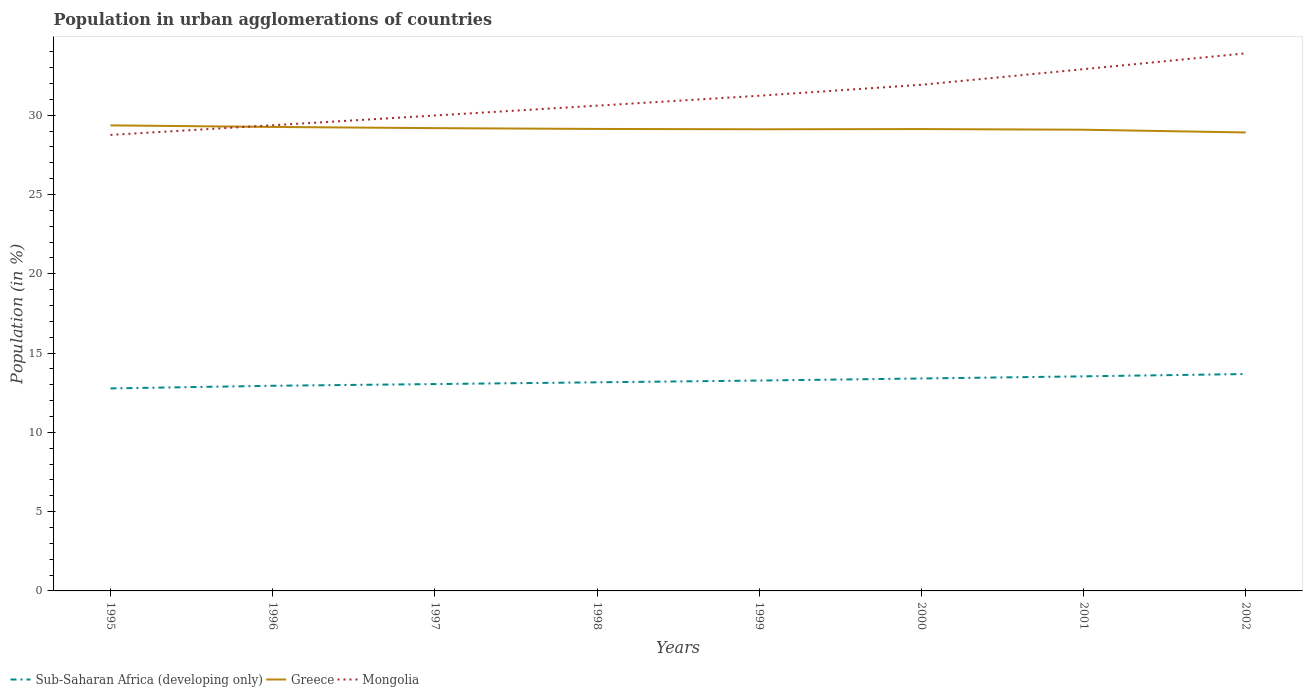Is the number of lines equal to the number of legend labels?
Your answer should be compact. Yes. Across all years, what is the maximum percentage of population in urban agglomerations in Greece?
Your response must be concise. 28.91. In which year was the percentage of population in urban agglomerations in Sub-Saharan Africa (developing only) maximum?
Your answer should be compact. 1995. What is the total percentage of population in urban agglomerations in Sub-Saharan Africa (developing only) in the graph?
Provide a short and direct response. -0.17. What is the difference between the highest and the second highest percentage of population in urban agglomerations in Greece?
Your answer should be very brief. 0.45. What is the difference between two consecutive major ticks on the Y-axis?
Keep it short and to the point. 5. Are the values on the major ticks of Y-axis written in scientific E-notation?
Your answer should be very brief. No. Does the graph contain grids?
Ensure brevity in your answer.  No. Where does the legend appear in the graph?
Keep it short and to the point. Bottom left. What is the title of the graph?
Offer a very short reply. Population in urban agglomerations of countries. Does "Oman" appear as one of the legend labels in the graph?
Your answer should be compact. No. What is the Population (in %) of Sub-Saharan Africa (developing only) in 1995?
Keep it short and to the point. 12.77. What is the Population (in %) of Greece in 1995?
Your answer should be compact. 29.35. What is the Population (in %) in Mongolia in 1995?
Your response must be concise. 28.75. What is the Population (in %) in Sub-Saharan Africa (developing only) in 1996?
Offer a terse response. 12.94. What is the Population (in %) in Greece in 1996?
Ensure brevity in your answer.  29.26. What is the Population (in %) of Mongolia in 1996?
Give a very brief answer. 29.36. What is the Population (in %) of Sub-Saharan Africa (developing only) in 1997?
Offer a very short reply. 13.04. What is the Population (in %) of Greece in 1997?
Offer a terse response. 29.18. What is the Population (in %) of Mongolia in 1997?
Your answer should be compact. 29.98. What is the Population (in %) of Sub-Saharan Africa (developing only) in 1998?
Your response must be concise. 13.15. What is the Population (in %) of Greece in 1998?
Provide a short and direct response. 29.13. What is the Population (in %) in Mongolia in 1998?
Make the answer very short. 30.6. What is the Population (in %) of Sub-Saharan Africa (developing only) in 1999?
Give a very brief answer. 13.27. What is the Population (in %) in Greece in 1999?
Your answer should be compact. 29.11. What is the Population (in %) in Mongolia in 1999?
Ensure brevity in your answer.  31.22. What is the Population (in %) of Sub-Saharan Africa (developing only) in 2000?
Make the answer very short. 13.4. What is the Population (in %) of Greece in 2000?
Offer a very short reply. 29.12. What is the Population (in %) of Mongolia in 2000?
Offer a very short reply. 31.91. What is the Population (in %) of Sub-Saharan Africa (developing only) in 2001?
Keep it short and to the point. 13.53. What is the Population (in %) in Greece in 2001?
Make the answer very short. 29.08. What is the Population (in %) in Mongolia in 2001?
Offer a very short reply. 32.9. What is the Population (in %) in Sub-Saharan Africa (developing only) in 2002?
Your answer should be compact. 13.67. What is the Population (in %) in Greece in 2002?
Offer a terse response. 28.91. What is the Population (in %) of Mongolia in 2002?
Provide a short and direct response. 33.9. Across all years, what is the maximum Population (in %) of Sub-Saharan Africa (developing only)?
Offer a very short reply. 13.67. Across all years, what is the maximum Population (in %) of Greece?
Keep it short and to the point. 29.35. Across all years, what is the maximum Population (in %) in Mongolia?
Ensure brevity in your answer.  33.9. Across all years, what is the minimum Population (in %) of Sub-Saharan Africa (developing only)?
Your answer should be compact. 12.77. Across all years, what is the minimum Population (in %) in Greece?
Your answer should be compact. 28.91. Across all years, what is the minimum Population (in %) in Mongolia?
Offer a very short reply. 28.75. What is the total Population (in %) in Sub-Saharan Africa (developing only) in the graph?
Your answer should be very brief. 105.77. What is the total Population (in %) in Greece in the graph?
Offer a terse response. 233.14. What is the total Population (in %) of Mongolia in the graph?
Your answer should be very brief. 248.62. What is the difference between the Population (in %) of Sub-Saharan Africa (developing only) in 1995 and that in 1996?
Provide a succinct answer. -0.17. What is the difference between the Population (in %) of Greece in 1995 and that in 1996?
Provide a succinct answer. 0.1. What is the difference between the Population (in %) of Mongolia in 1995 and that in 1996?
Provide a succinct answer. -0.61. What is the difference between the Population (in %) of Sub-Saharan Africa (developing only) in 1995 and that in 1997?
Provide a succinct answer. -0.27. What is the difference between the Population (in %) of Greece in 1995 and that in 1997?
Your answer should be compact. 0.17. What is the difference between the Population (in %) of Mongolia in 1995 and that in 1997?
Provide a succinct answer. -1.22. What is the difference between the Population (in %) of Sub-Saharan Africa (developing only) in 1995 and that in 1998?
Provide a short and direct response. -0.38. What is the difference between the Population (in %) in Greece in 1995 and that in 1998?
Offer a terse response. 0.22. What is the difference between the Population (in %) of Mongolia in 1995 and that in 1998?
Your answer should be very brief. -1.84. What is the difference between the Population (in %) in Sub-Saharan Africa (developing only) in 1995 and that in 1999?
Ensure brevity in your answer.  -0.5. What is the difference between the Population (in %) in Greece in 1995 and that in 1999?
Offer a very short reply. 0.25. What is the difference between the Population (in %) in Mongolia in 1995 and that in 1999?
Ensure brevity in your answer.  -2.47. What is the difference between the Population (in %) of Sub-Saharan Africa (developing only) in 1995 and that in 2000?
Provide a succinct answer. -0.63. What is the difference between the Population (in %) in Greece in 1995 and that in 2000?
Ensure brevity in your answer.  0.23. What is the difference between the Population (in %) of Mongolia in 1995 and that in 2000?
Ensure brevity in your answer.  -3.16. What is the difference between the Population (in %) of Sub-Saharan Africa (developing only) in 1995 and that in 2001?
Provide a short and direct response. -0.76. What is the difference between the Population (in %) in Greece in 1995 and that in 2001?
Make the answer very short. 0.27. What is the difference between the Population (in %) in Mongolia in 1995 and that in 2001?
Give a very brief answer. -4.14. What is the difference between the Population (in %) in Sub-Saharan Africa (developing only) in 1995 and that in 2002?
Your response must be concise. -0.91. What is the difference between the Population (in %) of Greece in 1995 and that in 2002?
Offer a very short reply. 0.45. What is the difference between the Population (in %) of Mongolia in 1995 and that in 2002?
Give a very brief answer. -5.14. What is the difference between the Population (in %) of Sub-Saharan Africa (developing only) in 1996 and that in 1997?
Your answer should be compact. -0.11. What is the difference between the Population (in %) of Greece in 1996 and that in 1997?
Make the answer very short. 0.08. What is the difference between the Population (in %) in Mongolia in 1996 and that in 1997?
Offer a very short reply. -0.61. What is the difference between the Population (in %) in Sub-Saharan Africa (developing only) in 1996 and that in 1998?
Offer a terse response. -0.22. What is the difference between the Population (in %) in Greece in 1996 and that in 1998?
Make the answer very short. 0.13. What is the difference between the Population (in %) in Mongolia in 1996 and that in 1998?
Give a very brief answer. -1.23. What is the difference between the Population (in %) of Sub-Saharan Africa (developing only) in 1996 and that in 1999?
Provide a short and direct response. -0.33. What is the difference between the Population (in %) in Greece in 1996 and that in 1999?
Ensure brevity in your answer.  0.15. What is the difference between the Population (in %) of Mongolia in 1996 and that in 1999?
Make the answer very short. -1.86. What is the difference between the Population (in %) of Sub-Saharan Africa (developing only) in 1996 and that in 2000?
Keep it short and to the point. -0.46. What is the difference between the Population (in %) in Greece in 1996 and that in 2000?
Your answer should be compact. 0.13. What is the difference between the Population (in %) in Mongolia in 1996 and that in 2000?
Ensure brevity in your answer.  -2.55. What is the difference between the Population (in %) of Sub-Saharan Africa (developing only) in 1996 and that in 2001?
Offer a terse response. -0.6. What is the difference between the Population (in %) in Greece in 1996 and that in 2001?
Offer a very short reply. 0.18. What is the difference between the Population (in %) of Mongolia in 1996 and that in 2001?
Provide a succinct answer. -3.54. What is the difference between the Population (in %) of Sub-Saharan Africa (developing only) in 1996 and that in 2002?
Make the answer very short. -0.74. What is the difference between the Population (in %) of Greece in 1996 and that in 2002?
Offer a very short reply. 0.35. What is the difference between the Population (in %) of Mongolia in 1996 and that in 2002?
Offer a very short reply. -4.53. What is the difference between the Population (in %) of Sub-Saharan Africa (developing only) in 1997 and that in 1998?
Your answer should be very brief. -0.11. What is the difference between the Population (in %) in Greece in 1997 and that in 1998?
Make the answer very short. 0.05. What is the difference between the Population (in %) in Mongolia in 1997 and that in 1998?
Your response must be concise. -0.62. What is the difference between the Population (in %) of Sub-Saharan Africa (developing only) in 1997 and that in 1999?
Offer a terse response. -0.22. What is the difference between the Population (in %) in Greece in 1997 and that in 1999?
Offer a very short reply. 0.07. What is the difference between the Population (in %) in Mongolia in 1997 and that in 1999?
Your response must be concise. -1.25. What is the difference between the Population (in %) of Sub-Saharan Africa (developing only) in 1997 and that in 2000?
Your answer should be compact. -0.35. What is the difference between the Population (in %) in Greece in 1997 and that in 2000?
Provide a succinct answer. 0.06. What is the difference between the Population (in %) in Mongolia in 1997 and that in 2000?
Your answer should be compact. -1.94. What is the difference between the Population (in %) in Sub-Saharan Africa (developing only) in 1997 and that in 2001?
Offer a very short reply. -0.49. What is the difference between the Population (in %) of Greece in 1997 and that in 2001?
Ensure brevity in your answer.  0.1. What is the difference between the Population (in %) in Mongolia in 1997 and that in 2001?
Provide a succinct answer. -2.92. What is the difference between the Population (in %) in Sub-Saharan Africa (developing only) in 1997 and that in 2002?
Give a very brief answer. -0.63. What is the difference between the Population (in %) in Greece in 1997 and that in 2002?
Your answer should be compact. 0.27. What is the difference between the Population (in %) in Mongolia in 1997 and that in 2002?
Offer a terse response. -3.92. What is the difference between the Population (in %) of Sub-Saharan Africa (developing only) in 1998 and that in 1999?
Ensure brevity in your answer.  -0.11. What is the difference between the Population (in %) of Greece in 1998 and that in 1999?
Your response must be concise. 0.02. What is the difference between the Population (in %) in Mongolia in 1998 and that in 1999?
Your response must be concise. -0.63. What is the difference between the Population (in %) in Sub-Saharan Africa (developing only) in 1998 and that in 2000?
Your response must be concise. -0.24. What is the difference between the Population (in %) in Greece in 1998 and that in 2000?
Your answer should be compact. 0.01. What is the difference between the Population (in %) in Mongolia in 1998 and that in 2000?
Provide a short and direct response. -1.32. What is the difference between the Population (in %) in Sub-Saharan Africa (developing only) in 1998 and that in 2001?
Provide a succinct answer. -0.38. What is the difference between the Population (in %) in Greece in 1998 and that in 2001?
Your response must be concise. 0.05. What is the difference between the Population (in %) in Mongolia in 1998 and that in 2001?
Your answer should be compact. -2.3. What is the difference between the Population (in %) of Sub-Saharan Africa (developing only) in 1998 and that in 2002?
Ensure brevity in your answer.  -0.52. What is the difference between the Population (in %) in Greece in 1998 and that in 2002?
Offer a very short reply. 0.22. What is the difference between the Population (in %) of Mongolia in 1998 and that in 2002?
Give a very brief answer. -3.3. What is the difference between the Population (in %) in Sub-Saharan Africa (developing only) in 1999 and that in 2000?
Your answer should be very brief. -0.13. What is the difference between the Population (in %) in Greece in 1999 and that in 2000?
Offer a terse response. -0.01. What is the difference between the Population (in %) in Mongolia in 1999 and that in 2000?
Make the answer very short. -0.69. What is the difference between the Population (in %) in Sub-Saharan Africa (developing only) in 1999 and that in 2001?
Provide a short and direct response. -0.27. What is the difference between the Population (in %) of Greece in 1999 and that in 2001?
Offer a very short reply. 0.03. What is the difference between the Population (in %) of Mongolia in 1999 and that in 2001?
Offer a very short reply. -1.68. What is the difference between the Population (in %) of Sub-Saharan Africa (developing only) in 1999 and that in 2002?
Offer a very short reply. -0.41. What is the difference between the Population (in %) in Greece in 1999 and that in 2002?
Offer a very short reply. 0.2. What is the difference between the Population (in %) of Mongolia in 1999 and that in 2002?
Offer a very short reply. -2.67. What is the difference between the Population (in %) of Sub-Saharan Africa (developing only) in 2000 and that in 2001?
Your answer should be compact. -0.14. What is the difference between the Population (in %) in Greece in 2000 and that in 2001?
Your answer should be compact. 0.04. What is the difference between the Population (in %) of Mongolia in 2000 and that in 2001?
Your answer should be compact. -0.98. What is the difference between the Population (in %) of Sub-Saharan Africa (developing only) in 2000 and that in 2002?
Offer a terse response. -0.28. What is the difference between the Population (in %) in Greece in 2000 and that in 2002?
Keep it short and to the point. 0.21. What is the difference between the Population (in %) of Mongolia in 2000 and that in 2002?
Your answer should be very brief. -1.98. What is the difference between the Population (in %) in Sub-Saharan Africa (developing only) in 2001 and that in 2002?
Keep it short and to the point. -0.14. What is the difference between the Population (in %) in Greece in 2001 and that in 2002?
Provide a short and direct response. 0.17. What is the difference between the Population (in %) in Mongolia in 2001 and that in 2002?
Your response must be concise. -1. What is the difference between the Population (in %) of Sub-Saharan Africa (developing only) in 1995 and the Population (in %) of Greece in 1996?
Offer a very short reply. -16.49. What is the difference between the Population (in %) in Sub-Saharan Africa (developing only) in 1995 and the Population (in %) in Mongolia in 1996?
Your answer should be compact. -16.59. What is the difference between the Population (in %) of Greece in 1995 and the Population (in %) of Mongolia in 1996?
Your response must be concise. -0.01. What is the difference between the Population (in %) in Sub-Saharan Africa (developing only) in 1995 and the Population (in %) in Greece in 1997?
Provide a short and direct response. -16.41. What is the difference between the Population (in %) of Sub-Saharan Africa (developing only) in 1995 and the Population (in %) of Mongolia in 1997?
Provide a short and direct response. -17.21. What is the difference between the Population (in %) in Greece in 1995 and the Population (in %) in Mongolia in 1997?
Provide a short and direct response. -0.62. What is the difference between the Population (in %) in Sub-Saharan Africa (developing only) in 1995 and the Population (in %) in Greece in 1998?
Offer a very short reply. -16.36. What is the difference between the Population (in %) of Sub-Saharan Africa (developing only) in 1995 and the Population (in %) of Mongolia in 1998?
Offer a terse response. -17.83. What is the difference between the Population (in %) of Greece in 1995 and the Population (in %) of Mongolia in 1998?
Your answer should be very brief. -1.24. What is the difference between the Population (in %) in Sub-Saharan Africa (developing only) in 1995 and the Population (in %) in Greece in 1999?
Your response must be concise. -16.34. What is the difference between the Population (in %) in Sub-Saharan Africa (developing only) in 1995 and the Population (in %) in Mongolia in 1999?
Your answer should be very brief. -18.45. What is the difference between the Population (in %) of Greece in 1995 and the Population (in %) of Mongolia in 1999?
Your answer should be compact. -1.87. What is the difference between the Population (in %) of Sub-Saharan Africa (developing only) in 1995 and the Population (in %) of Greece in 2000?
Give a very brief answer. -16.35. What is the difference between the Population (in %) of Sub-Saharan Africa (developing only) in 1995 and the Population (in %) of Mongolia in 2000?
Your response must be concise. -19.15. What is the difference between the Population (in %) in Greece in 1995 and the Population (in %) in Mongolia in 2000?
Your answer should be compact. -2.56. What is the difference between the Population (in %) of Sub-Saharan Africa (developing only) in 1995 and the Population (in %) of Greece in 2001?
Your answer should be very brief. -16.31. What is the difference between the Population (in %) in Sub-Saharan Africa (developing only) in 1995 and the Population (in %) in Mongolia in 2001?
Your response must be concise. -20.13. What is the difference between the Population (in %) in Greece in 1995 and the Population (in %) in Mongolia in 2001?
Provide a short and direct response. -3.54. What is the difference between the Population (in %) in Sub-Saharan Africa (developing only) in 1995 and the Population (in %) in Greece in 2002?
Keep it short and to the point. -16.14. What is the difference between the Population (in %) of Sub-Saharan Africa (developing only) in 1995 and the Population (in %) of Mongolia in 2002?
Give a very brief answer. -21.13. What is the difference between the Population (in %) of Greece in 1995 and the Population (in %) of Mongolia in 2002?
Your answer should be compact. -4.54. What is the difference between the Population (in %) in Sub-Saharan Africa (developing only) in 1996 and the Population (in %) in Greece in 1997?
Provide a short and direct response. -16.24. What is the difference between the Population (in %) of Sub-Saharan Africa (developing only) in 1996 and the Population (in %) of Mongolia in 1997?
Provide a succinct answer. -17.04. What is the difference between the Population (in %) of Greece in 1996 and the Population (in %) of Mongolia in 1997?
Ensure brevity in your answer.  -0.72. What is the difference between the Population (in %) of Sub-Saharan Africa (developing only) in 1996 and the Population (in %) of Greece in 1998?
Your response must be concise. -16.19. What is the difference between the Population (in %) in Sub-Saharan Africa (developing only) in 1996 and the Population (in %) in Mongolia in 1998?
Provide a succinct answer. -17.66. What is the difference between the Population (in %) in Greece in 1996 and the Population (in %) in Mongolia in 1998?
Your answer should be compact. -1.34. What is the difference between the Population (in %) of Sub-Saharan Africa (developing only) in 1996 and the Population (in %) of Greece in 1999?
Keep it short and to the point. -16.17. What is the difference between the Population (in %) in Sub-Saharan Africa (developing only) in 1996 and the Population (in %) in Mongolia in 1999?
Ensure brevity in your answer.  -18.29. What is the difference between the Population (in %) in Greece in 1996 and the Population (in %) in Mongolia in 1999?
Ensure brevity in your answer.  -1.97. What is the difference between the Population (in %) in Sub-Saharan Africa (developing only) in 1996 and the Population (in %) in Greece in 2000?
Provide a succinct answer. -16.19. What is the difference between the Population (in %) of Sub-Saharan Africa (developing only) in 1996 and the Population (in %) of Mongolia in 2000?
Your answer should be compact. -18.98. What is the difference between the Population (in %) of Greece in 1996 and the Population (in %) of Mongolia in 2000?
Your response must be concise. -2.66. What is the difference between the Population (in %) of Sub-Saharan Africa (developing only) in 1996 and the Population (in %) of Greece in 2001?
Offer a terse response. -16.15. What is the difference between the Population (in %) of Sub-Saharan Africa (developing only) in 1996 and the Population (in %) of Mongolia in 2001?
Offer a terse response. -19.96. What is the difference between the Population (in %) of Greece in 1996 and the Population (in %) of Mongolia in 2001?
Ensure brevity in your answer.  -3.64. What is the difference between the Population (in %) of Sub-Saharan Africa (developing only) in 1996 and the Population (in %) of Greece in 2002?
Your answer should be compact. -15.97. What is the difference between the Population (in %) of Sub-Saharan Africa (developing only) in 1996 and the Population (in %) of Mongolia in 2002?
Provide a short and direct response. -20.96. What is the difference between the Population (in %) of Greece in 1996 and the Population (in %) of Mongolia in 2002?
Your answer should be very brief. -4.64. What is the difference between the Population (in %) of Sub-Saharan Africa (developing only) in 1997 and the Population (in %) of Greece in 1998?
Offer a terse response. -16.09. What is the difference between the Population (in %) of Sub-Saharan Africa (developing only) in 1997 and the Population (in %) of Mongolia in 1998?
Offer a terse response. -17.55. What is the difference between the Population (in %) in Greece in 1997 and the Population (in %) in Mongolia in 1998?
Your response must be concise. -1.42. What is the difference between the Population (in %) in Sub-Saharan Africa (developing only) in 1997 and the Population (in %) in Greece in 1999?
Provide a succinct answer. -16.07. What is the difference between the Population (in %) in Sub-Saharan Africa (developing only) in 1997 and the Population (in %) in Mongolia in 1999?
Offer a terse response. -18.18. What is the difference between the Population (in %) in Greece in 1997 and the Population (in %) in Mongolia in 1999?
Your response must be concise. -2.04. What is the difference between the Population (in %) in Sub-Saharan Africa (developing only) in 1997 and the Population (in %) in Greece in 2000?
Give a very brief answer. -16.08. What is the difference between the Population (in %) of Sub-Saharan Africa (developing only) in 1997 and the Population (in %) of Mongolia in 2000?
Your answer should be very brief. -18.87. What is the difference between the Population (in %) in Greece in 1997 and the Population (in %) in Mongolia in 2000?
Give a very brief answer. -2.73. What is the difference between the Population (in %) in Sub-Saharan Africa (developing only) in 1997 and the Population (in %) in Greece in 2001?
Ensure brevity in your answer.  -16.04. What is the difference between the Population (in %) in Sub-Saharan Africa (developing only) in 1997 and the Population (in %) in Mongolia in 2001?
Give a very brief answer. -19.86. What is the difference between the Population (in %) in Greece in 1997 and the Population (in %) in Mongolia in 2001?
Your answer should be compact. -3.72. What is the difference between the Population (in %) in Sub-Saharan Africa (developing only) in 1997 and the Population (in %) in Greece in 2002?
Ensure brevity in your answer.  -15.86. What is the difference between the Population (in %) in Sub-Saharan Africa (developing only) in 1997 and the Population (in %) in Mongolia in 2002?
Your answer should be compact. -20.86. What is the difference between the Population (in %) of Greece in 1997 and the Population (in %) of Mongolia in 2002?
Make the answer very short. -4.72. What is the difference between the Population (in %) of Sub-Saharan Africa (developing only) in 1998 and the Population (in %) of Greece in 1999?
Make the answer very short. -15.95. What is the difference between the Population (in %) of Sub-Saharan Africa (developing only) in 1998 and the Population (in %) of Mongolia in 1999?
Provide a short and direct response. -18.07. What is the difference between the Population (in %) of Greece in 1998 and the Population (in %) of Mongolia in 1999?
Offer a very short reply. -2.09. What is the difference between the Population (in %) of Sub-Saharan Africa (developing only) in 1998 and the Population (in %) of Greece in 2000?
Provide a short and direct response. -15.97. What is the difference between the Population (in %) of Sub-Saharan Africa (developing only) in 1998 and the Population (in %) of Mongolia in 2000?
Your answer should be very brief. -18.76. What is the difference between the Population (in %) in Greece in 1998 and the Population (in %) in Mongolia in 2000?
Give a very brief answer. -2.78. What is the difference between the Population (in %) in Sub-Saharan Africa (developing only) in 1998 and the Population (in %) in Greece in 2001?
Make the answer very short. -15.93. What is the difference between the Population (in %) in Sub-Saharan Africa (developing only) in 1998 and the Population (in %) in Mongolia in 2001?
Your answer should be compact. -19.74. What is the difference between the Population (in %) in Greece in 1998 and the Population (in %) in Mongolia in 2001?
Provide a succinct answer. -3.77. What is the difference between the Population (in %) in Sub-Saharan Africa (developing only) in 1998 and the Population (in %) in Greece in 2002?
Make the answer very short. -15.75. What is the difference between the Population (in %) of Sub-Saharan Africa (developing only) in 1998 and the Population (in %) of Mongolia in 2002?
Ensure brevity in your answer.  -20.74. What is the difference between the Population (in %) of Greece in 1998 and the Population (in %) of Mongolia in 2002?
Provide a succinct answer. -4.77. What is the difference between the Population (in %) of Sub-Saharan Africa (developing only) in 1999 and the Population (in %) of Greece in 2000?
Ensure brevity in your answer.  -15.86. What is the difference between the Population (in %) in Sub-Saharan Africa (developing only) in 1999 and the Population (in %) in Mongolia in 2000?
Your answer should be very brief. -18.65. What is the difference between the Population (in %) in Greece in 1999 and the Population (in %) in Mongolia in 2000?
Your response must be concise. -2.81. What is the difference between the Population (in %) in Sub-Saharan Africa (developing only) in 1999 and the Population (in %) in Greece in 2001?
Your response must be concise. -15.82. What is the difference between the Population (in %) of Sub-Saharan Africa (developing only) in 1999 and the Population (in %) of Mongolia in 2001?
Ensure brevity in your answer.  -19.63. What is the difference between the Population (in %) in Greece in 1999 and the Population (in %) in Mongolia in 2001?
Make the answer very short. -3.79. What is the difference between the Population (in %) of Sub-Saharan Africa (developing only) in 1999 and the Population (in %) of Greece in 2002?
Give a very brief answer. -15.64. What is the difference between the Population (in %) in Sub-Saharan Africa (developing only) in 1999 and the Population (in %) in Mongolia in 2002?
Make the answer very short. -20.63. What is the difference between the Population (in %) in Greece in 1999 and the Population (in %) in Mongolia in 2002?
Your answer should be compact. -4.79. What is the difference between the Population (in %) in Sub-Saharan Africa (developing only) in 2000 and the Population (in %) in Greece in 2001?
Your answer should be very brief. -15.69. What is the difference between the Population (in %) of Sub-Saharan Africa (developing only) in 2000 and the Population (in %) of Mongolia in 2001?
Provide a short and direct response. -19.5. What is the difference between the Population (in %) of Greece in 2000 and the Population (in %) of Mongolia in 2001?
Provide a short and direct response. -3.78. What is the difference between the Population (in %) of Sub-Saharan Africa (developing only) in 2000 and the Population (in %) of Greece in 2002?
Your response must be concise. -15.51. What is the difference between the Population (in %) of Sub-Saharan Africa (developing only) in 2000 and the Population (in %) of Mongolia in 2002?
Make the answer very short. -20.5. What is the difference between the Population (in %) in Greece in 2000 and the Population (in %) in Mongolia in 2002?
Provide a short and direct response. -4.78. What is the difference between the Population (in %) of Sub-Saharan Africa (developing only) in 2001 and the Population (in %) of Greece in 2002?
Your response must be concise. -15.38. What is the difference between the Population (in %) in Sub-Saharan Africa (developing only) in 2001 and the Population (in %) in Mongolia in 2002?
Your response must be concise. -20.37. What is the difference between the Population (in %) in Greece in 2001 and the Population (in %) in Mongolia in 2002?
Keep it short and to the point. -4.82. What is the average Population (in %) of Sub-Saharan Africa (developing only) per year?
Your answer should be very brief. 13.22. What is the average Population (in %) of Greece per year?
Offer a very short reply. 29.14. What is the average Population (in %) in Mongolia per year?
Your response must be concise. 31.08. In the year 1995, what is the difference between the Population (in %) in Sub-Saharan Africa (developing only) and Population (in %) in Greece?
Provide a short and direct response. -16.59. In the year 1995, what is the difference between the Population (in %) in Sub-Saharan Africa (developing only) and Population (in %) in Mongolia?
Ensure brevity in your answer.  -15.98. In the year 1995, what is the difference between the Population (in %) of Greece and Population (in %) of Mongolia?
Give a very brief answer. 0.6. In the year 1996, what is the difference between the Population (in %) of Sub-Saharan Africa (developing only) and Population (in %) of Greece?
Give a very brief answer. -16.32. In the year 1996, what is the difference between the Population (in %) of Sub-Saharan Africa (developing only) and Population (in %) of Mongolia?
Give a very brief answer. -16.43. In the year 1996, what is the difference between the Population (in %) in Greece and Population (in %) in Mongolia?
Give a very brief answer. -0.11. In the year 1997, what is the difference between the Population (in %) of Sub-Saharan Africa (developing only) and Population (in %) of Greece?
Make the answer very short. -16.14. In the year 1997, what is the difference between the Population (in %) of Sub-Saharan Africa (developing only) and Population (in %) of Mongolia?
Give a very brief answer. -16.93. In the year 1997, what is the difference between the Population (in %) of Greece and Population (in %) of Mongolia?
Your answer should be compact. -0.8. In the year 1998, what is the difference between the Population (in %) in Sub-Saharan Africa (developing only) and Population (in %) in Greece?
Make the answer very short. -15.98. In the year 1998, what is the difference between the Population (in %) of Sub-Saharan Africa (developing only) and Population (in %) of Mongolia?
Offer a very short reply. -17.44. In the year 1998, what is the difference between the Population (in %) of Greece and Population (in %) of Mongolia?
Offer a terse response. -1.47. In the year 1999, what is the difference between the Population (in %) of Sub-Saharan Africa (developing only) and Population (in %) of Greece?
Make the answer very short. -15.84. In the year 1999, what is the difference between the Population (in %) of Sub-Saharan Africa (developing only) and Population (in %) of Mongolia?
Offer a terse response. -17.96. In the year 1999, what is the difference between the Population (in %) in Greece and Population (in %) in Mongolia?
Give a very brief answer. -2.11. In the year 2000, what is the difference between the Population (in %) in Sub-Saharan Africa (developing only) and Population (in %) in Greece?
Provide a short and direct response. -15.73. In the year 2000, what is the difference between the Population (in %) in Sub-Saharan Africa (developing only) and Population (in %) in Mongolia?
Your response must be concise. -18.52. In the year 2000, what is the difference between the Population (in %) of Greece and Population (in %) of Mongolia?
Provide a short and direct response. -2.79. In the year 2001, what is the difference between the Population (in %) of Sub-Saharan Africa (developing only) and Population (in %) of Greece?
Offer a terse response. -15.55. In the year 2001, what is the difference between the Population (in %) of Sub-Saharan Africa (developing only) and Population (in %) of Mongolia?
Your response must be concise. -19.37. In the year 2001, what is the difference between the Population (in %) in Greece and Population (in %) in Mongolia?
Your response must be concise. -3.82. In the year 2002, what is the difference between the Population (in %) in Sub-Saharan Africa (developing only) and Population (in %) in Greece?
Keep it short and to the point. -15.23. In the year 2002, what is the difference between the Population (in %) of Sub-Saharan Africa (developing only) and Population (in %) of Mongolia?
Provide a succinct answer. -20.22. In the year 2002, what is the difference between the Population (in %) of Greece and Population (in %) of Mongolia?
Give a very brief answer. -4.99. What is the ratio of the Population (in %) in Sub-Saharan Africa (developing only) in 1995 to that in 1996?
Give a very brief answer. 0.99. What is the ratio of the Population (in %) in Mongolia in 1995 to that in 1996?
Offer a very short reply. 0.98. What is the ratio of the Population (in %) in Sub-Saharan Africa (developing only) in 1995 to that in 1997?
Your response must be concise. 0.98. What is the ratio of the Population (in %) of Mongolia in 1995 to that in 1997?
Offer a terse response. 0.96. What is the ratio of the Population (in %) of Sub-Saharan Africa (developing only) in 1995 to that in 1998?
Give a very brief answer. 0.97. What is the ratio of the Population (in %) of Greece in 1995 to that in 1998?
Your answer should be very brief. 1.01. What is the ratio of the Population (in %) of Mongolia in 1995 to that in 1998?
Your answer should be compact. 0.94. What is the ratio of the Population (in %) in Sub-Saharan Africa (developing only) in 1995 to that in 1999?
Keep it short and to the point. 0.96. What is the ratio of the Population (in %) of Greece in 1995 to that in 1999?
Offer a very short reply. 1.01. What is the ratio of the Population (in %) of Mongolia in 1995 to that in 1999?
Make the answer very short. 0.92. What is the ratio of the Population (in %) in Sub-Saharan Africa (developing only) in 1995 to that in 2000?
Offer a very short reply. 0.95. What is the ratio of the Population (in %) of Greece in 1995 to that in 2000?
Ensure brevity in your answer.  1.01. What is the ratio of the Population (in %) in Mongolia in 1995 to that in 2000?
Your response must be concise. 0.9. What is the ratio of the Population (in %) in Sub-Saharan Africa (developing only) in 1995 to that in 2001?
Give a very brief answer. 0.94. What is the ratio of the Population (in %) in Greece in 1995 to that in 2001?
Make the answer very short. 1.01. What is the ratio of the Population (in %) in Mongolia in 1995 to that in 2001?
Your answer should be compact. 0.87. What is the ratio of the Population (in %) of Sub-Saharan Africa (developing only) in 1995 to that in 2002?
Keep it short and to the point. 0.93. What is the ratio of the Population (in %) of Greece in 1995 to that in 2002?
Provide a short and direct response. 1.02. What is the ratio of the Population (in %) of Mongolia in 1995 to that in 2002?
Ensure brevity in your answer.  0.85. What is the ratio of the Population (in %) of Mongolia in 1996 to that in 1997?
Ensure brevity in your answer.  0.98. What is the ratio of the Population (in %) in Sub-Saharan Africa (developing only) in 1996 to that in 1998?
Offer a terse response. 0.98. What is the ratio of the Population (in %) in Mongolia in 1996 to that in 1998?
Your answer should be very brief. 0.96. What is the ratio of the Population (in %) of Sub-Saharan Africa (developing only) in 1996 to that in 1999?
Make the answer very short. 0.98. What is the ratio of the Population (in %) in Greece in 1996 to that in 1999?
Make the answer very short. 1.01. What is the ratio of the Population (in %) of Mongolia in 1996 to that in 1999?
Your response must be concise. 0.94. What is the ratio of the Population (in %) in Sub-Saharan Africa (developing only) in 1996 to that in 2000?
Provide a succinct answer. 0.97. What is the ratio of the Population (in %) in Mongolia in 1996 to that in 2000?
Offer a terse response. 0.92. What is the ratio of the Population (in %) in Sub-Saharan Africa (developing only) in 1996 to that in 2001?
Make the answer very short. 0.96. What is the ratio of the Population (in %) of Greece in 1996 to that in 2001?
Provide a short and direct response. 1.01. What is the ratio of the Population (in %) of Mongolia in 1996 to that in 2001?
Offer a terse response. 0.89. What is the ratio of the Population (in %) in Sub-Saharan Africa (developing only) in 1996 to that in 2002?
Provide a succinct answer. 0.95. What is the ratio of the Population (in %) in Greece in 1996 to that in 2002?
Ensure brevity in your answer.  1.01. What is the ratio of the Population (in %) in Mongolia in 1996 to that in 2002?
Your response must be concise. 0.87. What is the ratio of the Population (in %) in Greece in 1997 to that in 1998?
Provide a succinct answer. 1. What is the ratio of the Population (in %) of Mongolia in 1997 to that in 1998?
Keep it short and to the point. 0.98. What is the ratio of the Population (in %) of Sub-Saharan Africa (developing only) in 1997 to that in 1999?
Offer a very short reply. 0.98. What is the ratio of the Population (in %) in Greece in 1997 to that in 1999?
Offer a very short reply. 1. What is the ratio of the Population (in %) in Mongolia in 1997 to that in 1999?
Your answer should be very brief. 0.96. What is the ratio of the Population (in %) of Sub-Saharan Africa (developing only) in 1997 to that in 2000?
Offer a terse response. 0.97. What is the ratio of the Population (in %) of Greece in 1997 to that in 2000?
Ensure brevity in your answer.  1. What is the ratio of the Population (in %) in Mongolia in 1997 to that in 2000?
Keep it short and to the point. 0.94. What is the ratio of the Population (in %) in Sub-Saharan Africa (developing only) in 1997 to that in 2001?
Offer a terse response. 0.96. What is the ratio of the Population (in %) of Greece in 1997 to that in 2001?
Provide a short and direct response. 1. What is the ratio of the Population (in %) in Mongolia in 1997 to that in 2001?
Make the answer very short. 0.91. What is the ratio of the Population (in %) in Sub-Saharan Africa (developing only) in 1997 to that in 2002?
Provide a short and direct response. 0.95. What is the ratio of the Population (in %) in Greece in 1997 to that in 2002?
Give a very brief answer. 1.01. What is the ratio of the Population (in %) of Mongolia in 1997 to that in 2002?
Make the answer very short. 0.88. What is the ratio of the Population (in %) of Sub-Saharan Africa (developing only) in 1998 to that in 1999?
Offer a terse response. 0.99. What is the ratio of the Population (in %) in Mongolia in 1998 to that in 1999?
Provide a short and direct response. 0.98. What is the ratio of the Population (in %) of Sub-Saharan Africa (developing only) in 1998 to that in 2000?
Your answer should be compact. 0.98. What is the ratio of the Population (in %) of Mongolia in 1998 to that in 2000?
Give a very brief answer. 0.96. What is the ratio of the Population (in %) of Sub-Saharan Africa (developing only) in 1998 to that in 2001?
Your answer should be very brief. 0.97. What is the ratio of the Population (in %) of Greece in 1998 to that in 2001?
Your response must be concise. 1. What is the ratio of the Population (in %) of Sub-Saharan Africa (developing only) in 1998 to that in 2002?
Make the answer very short. 0.96. What is the ratio of the Population (in %) of Greece in 1998 to that in 2002?
Provide a succinct answer. 1.01. What is the ratio of the Population (in %) of Mongolia in 1998 to that in 2002?
Your response must be concise. 0.9. What is the ratio of the Population (in %) of Sub-Saharan Africa (developing only) in 1999 to that in 2000?
Keep it short and to the point. 0.99. What is the ratio of the Population (in %) of Greece in 1999 to that in 2000?
Offer a terse response. 1. What is the ratio of the Population (in %) in Mongolia in 1999 to that in 2000?
Your answer should be very brief. 0.98. What is the ratio of the Population (in %) of Sub-Saharan Africa (developing only) in 1999 to that in 2001?
Offer a terse response. 0.98. What is the ratio of the Population (in %) in Greece in 1999 to that in 2001?
Provide a short and direct response. 1. What is the ratio of the Population (in %) in Mongolia in 1999 to that in 2001?
Provide a short and direct response. 0.95. What is the ratio of the Population (in %) in Sub-Saharan Africa (developing only) in 1999 to that in 2002?
Provide a succinct answer. 0.97. What is the ratio of the Population (in %) of Greece in 1999 to that in 2002?
Your answer should be very brief. 1.01. What is the ratio of the Population (in %) in Mongolia in 1999 to that in 2002?
Your answer should be very brief. 0.92. What is the ratio of the Population (in %) in Greece in 2000 to that in 2001?
Your answer should be very brief. 1. What is the ratio of the Population (in %) of Mongolia in 2000 to that in 2001?
Your answer should be very brief. 0.97. What is the ratio of the Population (in %) in Sub-Saharan Africa (developing only) in 2000 to that in 2002?
Your answer should be compact. 0.98. What is the ratio of the Population (in %) in Greece in 2000 to that in 2002?
Your answer should be compact. 1.01. What is the ratio of the Population (in %) in Mongolia in 2000 to that in 2002?
Offer a very short reply. 0.94. What is the ratio of the Population (in %) in Greece in 2001 to that in 2002?
Your answer should be very brief. 1.01. What is the ratio of the Population (in %) of Mongolia in 2001 to that in 2002?
Offer a very short reply. 0.97. What is the difference between the highest and the second highest Population (in %) in Sub-Saharan Africa (developing only)?
Ensure brevity in your answer.  0.14. What is the difference between the highest and the second highest Population (in %) in Greece?
Offer a very short reply. 0.1. What is the difference between the highest and the second highest Population (in %) of Mongolia?
Your answer should be compact. 1. What is the difference between the highest and the lowest Population (in %) of Sub-Saharan Africa (developing only)?
Keep it short and to the point. 0.91. What is the difference between the highest and the lowest Population (in %) in Greece?
Keep it short and to the point. 0.45. What is the difference between the highest and the lowest Population (in %) of Mongolia?
Ensure brevity in your answer.  5.14. 